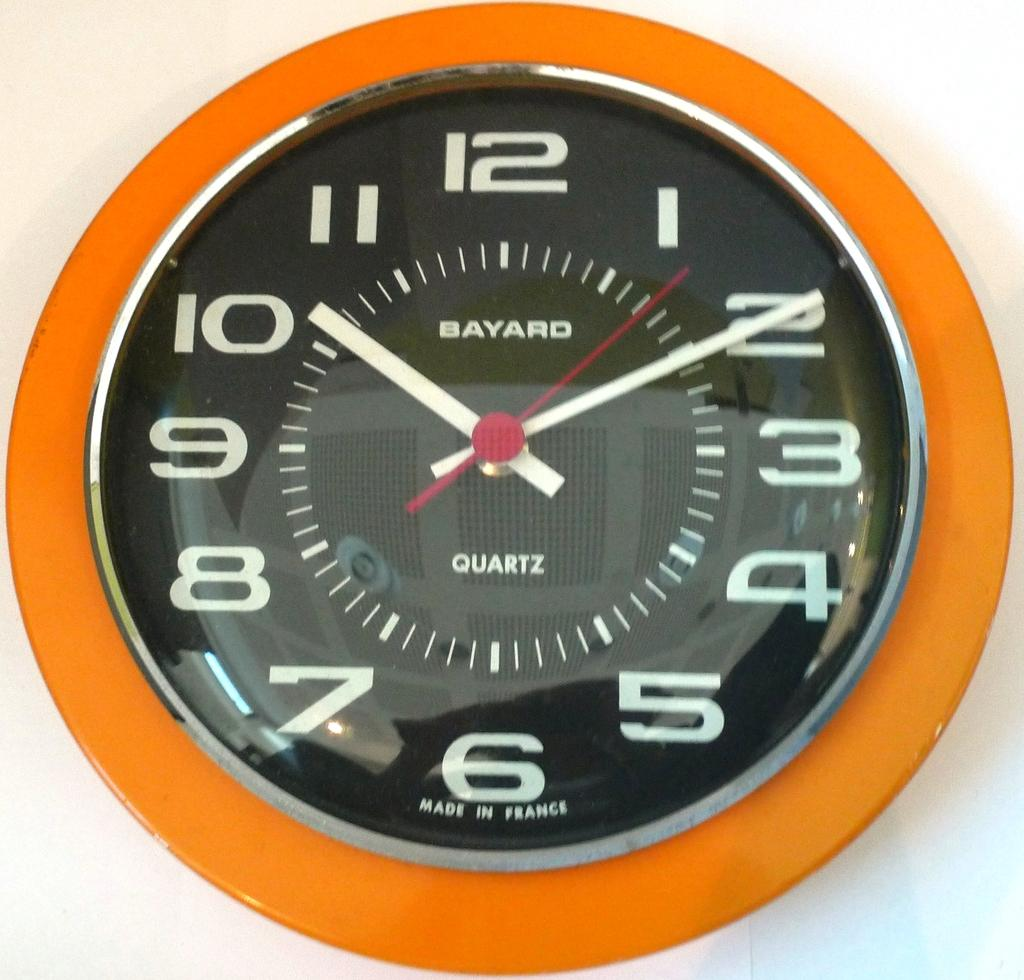Provide a one-sentence caption for the provided image. The bayard wall clock made from quartz hanging on the wall. 